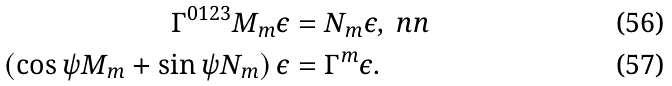<formula> <loc_0><loc_0><loc_500><loc_500>\Gamma ^ { 0 1 2 3 } M _ { m } \epsilon & = N _ { m } \epsilon , \ n n \\ \left ( \cos \psi M _ { m } + \sin \psi N _ { m } \right ) \epsilon & = \Gamma ^ { m } \epsilon .</formula> 